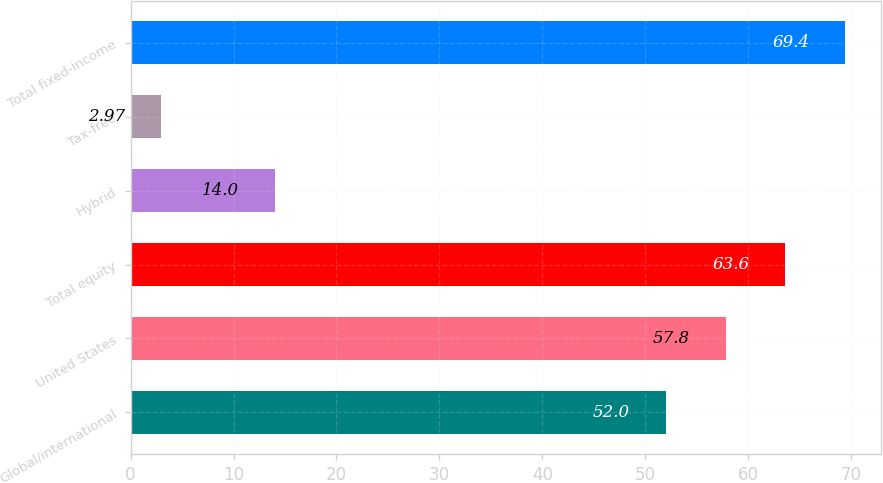<chart> <loc_0><loc_0><loc_500><loc_500><bar_chart><fcel>Global/international<fcel>United States<fcel>Total equity<fcel>Hybrid<fcel>Tax-free<fcel>Total fixed-income<nl><fcel>52<fcel>57.8<fcel>63.6<fcel>14<fcel>2.97<fcel>69.4<nl></chart> 